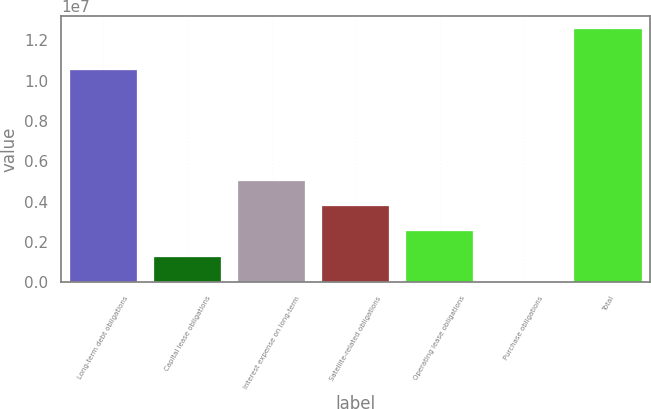Convert chart. <chart><loc_0><loc_0><loc_500><loc_500><bar_chart><fcel>Long-term debt obligations<fcel>Capital lease obligations<fcel>Interest expense on long-term<fcel>Satellite-related obligations<fcel>Operating lease obligations<fcel>Purchase obligations<fcel>Total<nl><fcel>1.05259e+07<fcel>1.26356e+06<fcel>5.03566e+06<fcel>3.77829e+06<fcel>2.52093e+06<fcel>6200<fcel>1.25798e+07<nl></chart> 